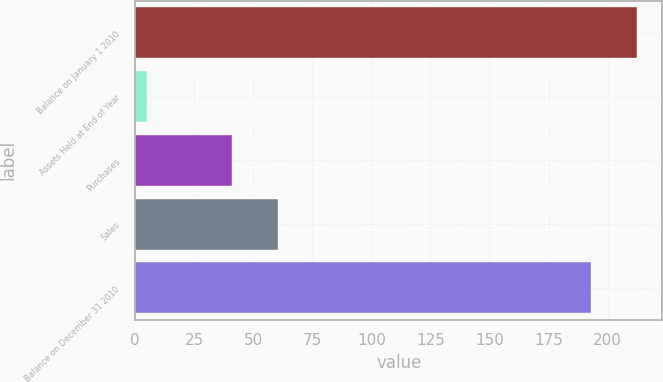Convert chart to OTSL. <chart><loc_0><loc_0><loc_500><loc_500><bar_chart><fcel>Balance on January 1 2010<fcel>Assets Held at End of Year<fcel>Purchases<fcel>Sales<fcel>Balance on December 31 2010<nl><fcel>212.6<fcel>5<fcel>41<fcel>60.6<fcel>193<nl></chart> 